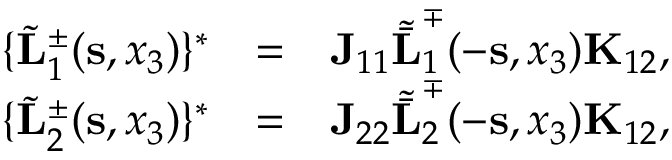<formula> <loc_0><loc_0><loc_500><loc_500>\begin{array} { r l r } { \{ \tilde { L } _ { 1 } ^ { \pm } ( { s } , x _ { 3 } ) \} ^ { * } } & { = } & { { J } _ { 1 1 } { \tilde { \bar { L } } } _ { 1 } ^ { \mp } ( - { s } , x _ { 3 } ) { K } _ { 1 2 } , } \\ { \{ \tilde { L } _ { 2 } ^ { \pm } ( { s } , x _ { 3 } ) \} ^ { * } } & { = } & { { J } _ { 2 2 } { \tilde { \bar { L } } } _ { 2 } ^ { \mp } ( - { s } , x _ { 3 } ) { K } _ { 1 2 } , } \end{array}</formula> 